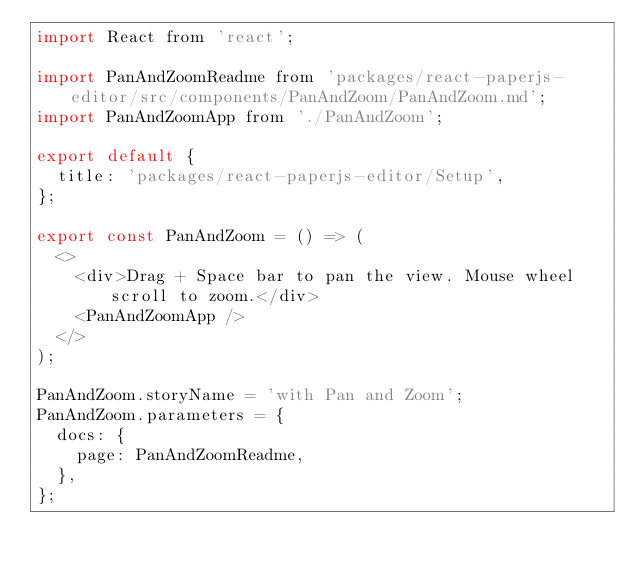<code> <loc_0><loc_0><loc_500><loc_500><_JavaScript_>import React from 'react';

import PanAndZoomReadme from 'packages/react-paperjs-editor/src/components/PanAndZoom/PanAndZoom.md';
import PanAndZoomApp from './PanAndZoom';

export default {
  title: 'packages/react-paperjs-editor/Setup',
};

export const PanAndZoom = () => (
  <>
    <div>Drag + Space bar to pan the view. Mouse wheel scroll to zoom.</div>
    <PanAndZoomApp />
  </>
);

PanAndZoom.storyName = 'with Pan and Zoom';
PanAndZoom.parameters = {
  docs: {
    page: PanAndZoomReadme,
  },
};
</code> 